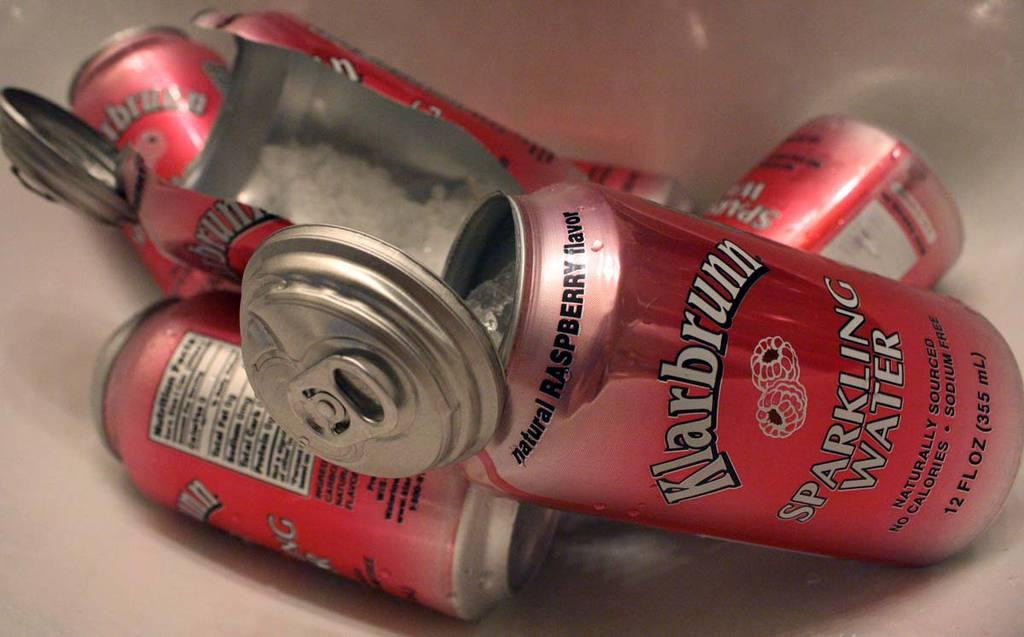Provide a one-sentence caption for the provided image. Several cans that are cut open and labeled as sparkling water. 